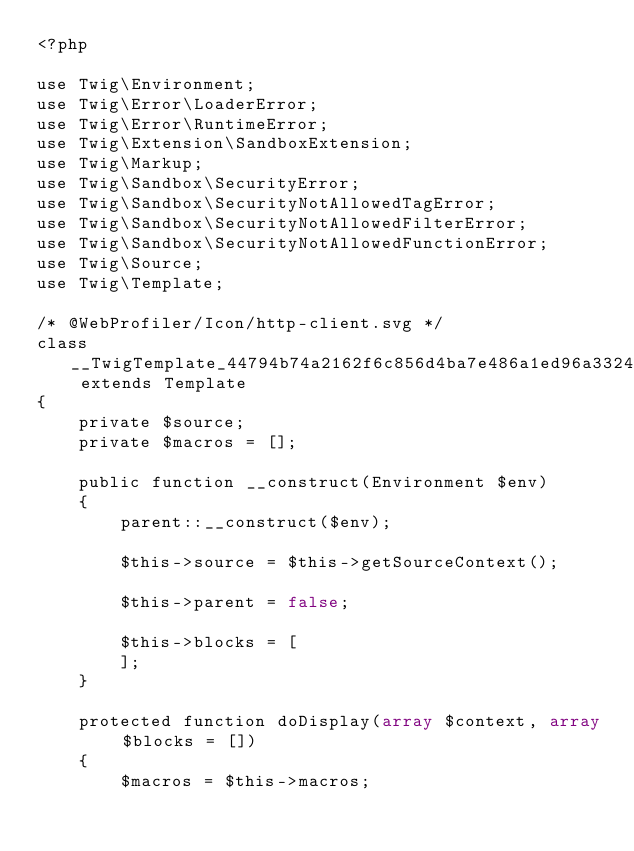Convert code to text. <code><loc_0><loc_0><loc_500><loc_500><_PHP_><?php

use Twig\Environment;
use Twig\Error\LoaderError;
use Twig\Error\RuntimeError;
use Twig\Extension\SandboxExtension;
use Twig\Markup;
use Twig\Sandbox\SecurityError;
use Twig\Sandbox\SecurityNotAllowedTagError;
use Twig\Sandbox\SecurityNotAllowedFilterError;
use Twig\Sandbox\SecurityNotAllowedFunctionError;
use Twig\Source;
use Twig\Template;

/* @WebProfiler/Icon/http-client.svg */
class __TwigTemplate_44794b74a2162f6c856d4ba7e486a1ed96a3324f7ef8cb84b09877f82ca6e564 extends Template
{
    private $source;
    private $macros = [];

    public function __construct(Environment $env)
    {
        parent::__construct($env);

        $this->source = $this->getSourceContext();

        $this->parent = false;

        $this->blocks = [
        ];
    }

    protected function doDisplay(array $context, array $blocks = [])
    {
        $macros = $this->macros;</code> 